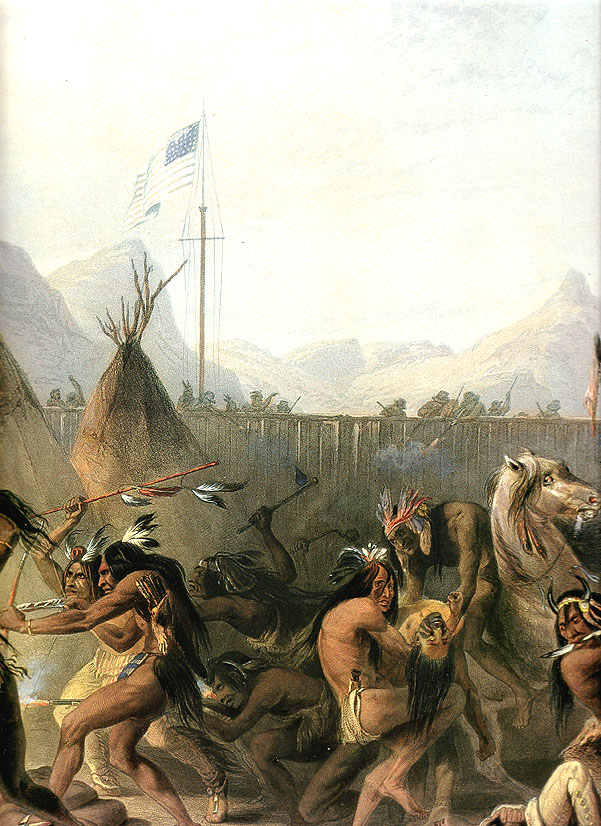Can you describe the scene in the painting in more detail? Certainly! The painting shows a vibrant and bustling scene from a historical moment. In the foreground, we see a group of Native Americans performing a dance, their movements full of life and energy. They are dressed in traditional attire, including feathered headdresses and fringed garments, which sway with their dance. The figures are arranged in a dynamic circle, symbolizing unity and continuity. On one side, a horse stands, seemingly part of the gathering. The backdrop features a detailed depiction of mountains and greenery, providing a natural and serene setting that contrasts with the lively activity in the forefront. Traditional teepees are also visible, indicating a sense of community. A flagpole with an American flag rises in the background, introducing a juxtaposition of cultures. The overall composition, with its careful attention to detail and historical context, offers a rich visual narrative that speaks to the cultural interactions and traditions of the time. What emotions do you think are depicted in the faces and body language of the figures? The emotions depicted in the faces and body language of the figures seem to convey a mix of intensity, focus, and communal spirit. The furrowed brows, open mouths, and animated expressions suggest that the participants are deeply engrossed in the dance, perhaps performing a ritual of significant cultural importance. Their body language, marked by vigorous movements and fluid gestures, indicates a high level of energy and emotional involvement. The dance could be a celebratory or ceremonial act, reflecting joy, spirituality, unity, and a connection to their heritage. The intensity of their engagement suggests not just a physical performance, but an emotional and spiritual experience shared by the community. Imagine a story behind this scene. What event might they be celebrating or commemorating? In a setting surrounded by natural beauty, the painting could commemorate a significant event in the tribe's history. Let’s imagine that they are celebrating a successful harvest, partaking in an annual dance that has been passed down through generations. The American flag signifies recent peaceful negotiations or a new alliance with neighboring settlers, promising mutual respect and cohabitation in the new environment. The dance is performed to honor their ancestors, to thank the spirits for the bountiful harvest, and to celebrate the newfound peace. As they dance, they are not just creating a vibrant tradition for the current generation but also encapsulating the resilience, joy, and hope that mark their cultural identity. 